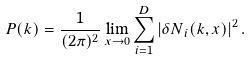Convert formula to latex. <formula><loc_0><loc_0><loc_500><loc_500>P ( k ) = \frac { 1 } { ( 2 \pi ) ^ { 2 } } \lim _ { x \rightarrow 0 } \sum _ { i = 1 } ^ { D } \left | { \delta N } _ { i } ( k , x ) \right | ^ { 2 } .</formula> 